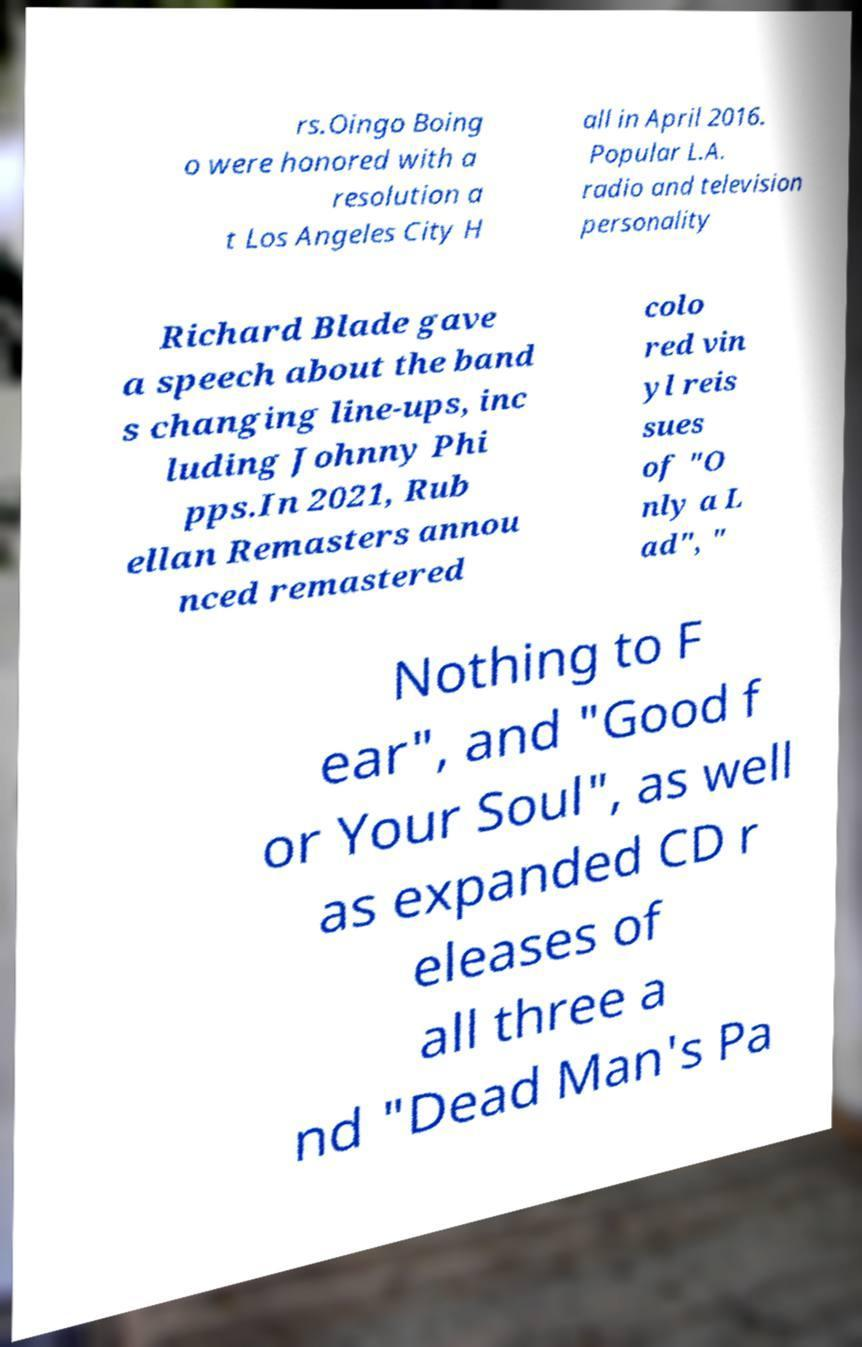Please identify and transcribe the text found in this image. rs.Oingo Boing o were honored with a resolution a t Los Angeles City H all in April 2016. Popular L.A. radio and television personality Richard Blade gave a speech about the band s changing line-ups, inc luding Johnny Phi pps.In 2021, Rub ellan Remasters annou nced remastered colo red vin yl reis sues of "O nly a L ad", " Nothing to F ear", and "Good f or Your Soul", as well as expanded CD r eleases of all three a nd "Dead Man's Pa 